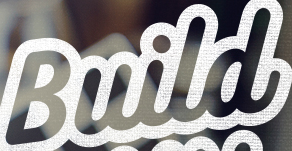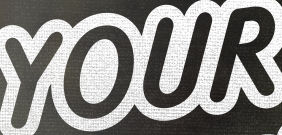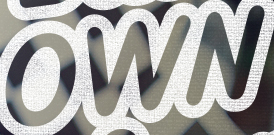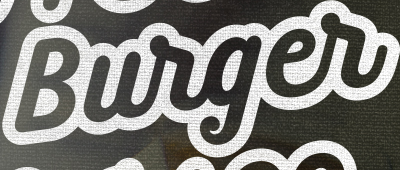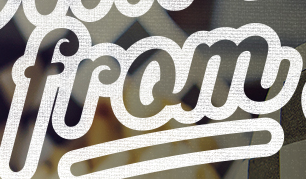Read the text content from these images in order, separated by a semicolon. Build; YOUR; OWN; Burger; from 